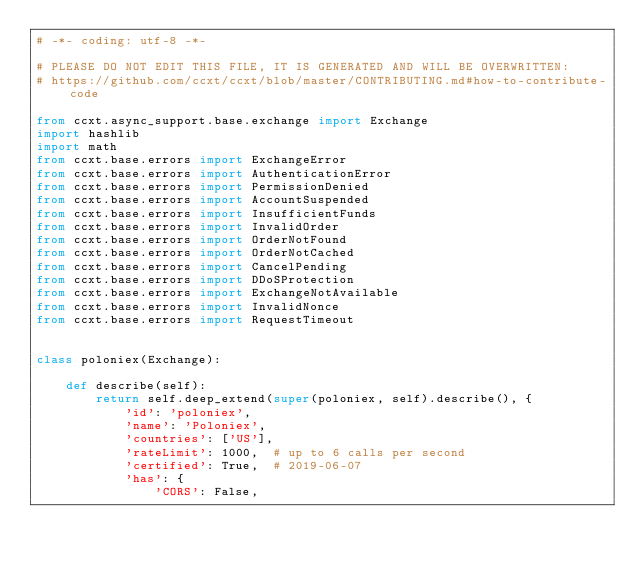<code> <loc_0><loc_0><loc_500><loc_500><_Python_># -*- coding: utf-8 -*-

# PLEASE DO NOT EDIT THIS FILE, IT IS GENERATED AND WILL BE OVERWRITTEN:
# https://github.com/ccxt/ccxt/blob/master/CONTRIBUTING.md#how-to-contribute-code

from ccxt.async_support.base.exchange import Exchange
import hashlib
import math
from ccxt.base.errors import ExchangeError
from ccxt.base.errors import AuthenticationError
from ccxt.base.errors import PermissionDenied
from ccxt.base.errors import AccountSuspended
from ccxt.base.errors import InsufficientFunds
from ccxt.base.errors import InvalidOrder
from ccxt.base.errors import OrderNotFound
from ccxt.base.errors import OrderNotCached
from ccxt.base.errors import CancelPending
from ccxt.base.errors import DDoSProtection
from ccxt.base.errors import ExchangeNotAvailable
from ccxt.base.errors import InvalidNonce
from ccxt.base.errors import RequestTimeout


class poloniex(Exchange):

    def describe(self):
        return self.deep_extend(super(poloniex, self).describe(), {
            'id': 'poloniex',
            'name': 'Poloniex',
            'countries': ['US'],
            'rateLimit': 1000,  # up to 6 calls per second
            'certified': True,  # 2019-06-07
            'has': {
                'CORS': False,</code> 